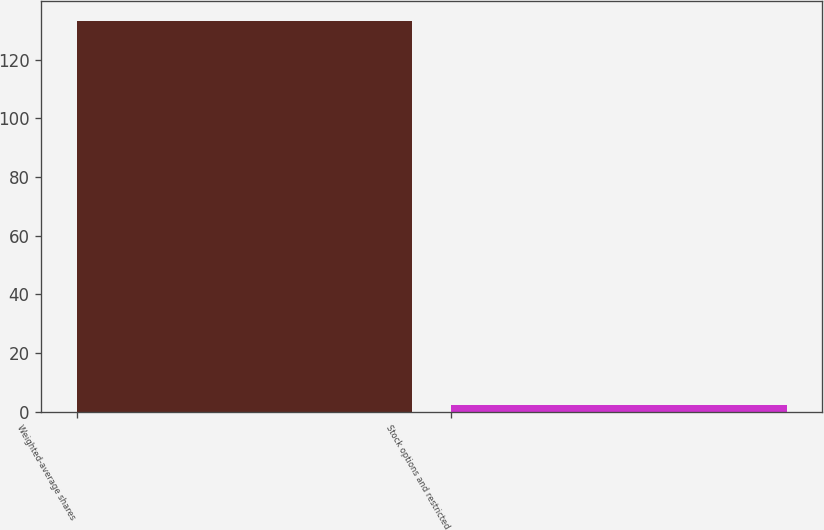<chart> <loc_0><loc_0><loc_500><loc_500><bar_chart><fcel>Weighted-average shares<fcel>Stock options and restricted<nl><fcel>133.32<fcel>2.3<nl></chart> 